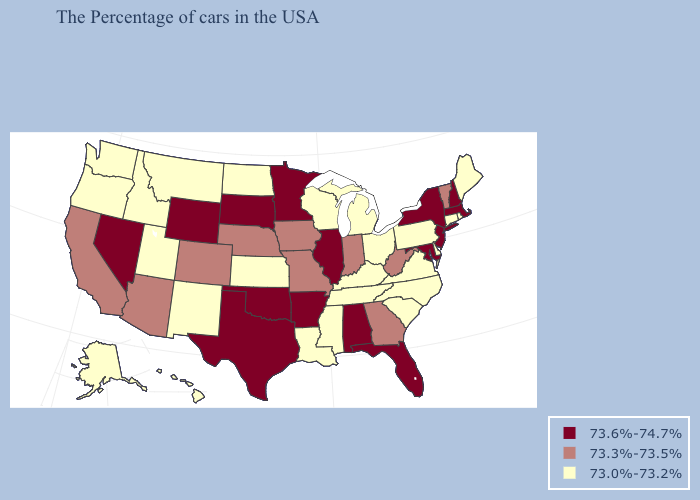Does the map have missing data?
Answer briefly. No. Name the states that have a value in the range 73.6%-74.7%?
Concise answer only. Massachusetts, New Hampshire, New York, New Jersey, Maryland, Florida, Alabama, Illinois, Arkansas, Minnesota, Oklahoma, Texas, South Dakota, Wyoming, Nevada. Among the states that border Tennessee , which have the lowest value?
Short answer required. Virginia, North Carolina, Kentucky, Mississippi. What is the highest value in states that border Washington?
Give a very brief answer. 73.0%-73.2%. What is the value of Alabama?
Keep it brief. 73.6%-74.7%. Does New Mexico have the same value as Connecticut?
Keep it brief. Yes. What is the lowest value in the South?
Keep it brief. 73.0%-73.2%. Name the states that have a value in the range 73.3%-73.5%?
Concise answer only. Vermont, West Virginia, Georgia, Indiana, Missouri, Iowa, Nebraska, Colorado, Arizona, California. What is the value of Wisconsin?
Keep it brief. 73.0%-73.2%. What is the highest value in the USA?
Quick response, please. 73.6%-74.7%. What is the highest value in the USA?
Be succinct. 73.6%-74.7%. Name the states that have a value in the range 73.0%-73.2%?
Quick response, please. Maine, Rhode Island, Connecticut, Delaware, Pennsylvania, Virginia, North Carolina, South Carolina, Ohio, Michigan, Kentucky, Tennessee, Wisconsin, Mississippi, Louisiana, Kansas, North Dakota, New Mexico, Utah, Montana, Idaho, Washington, Oregon, Alaska, Hawaii. How many symbols are there in the legend?
Quick response, please. 3. Does Tennessee have the same value as Washington?
Short answer required. Yes. Does Kentucky have the highest value in the South?
Answer briefly. No. 